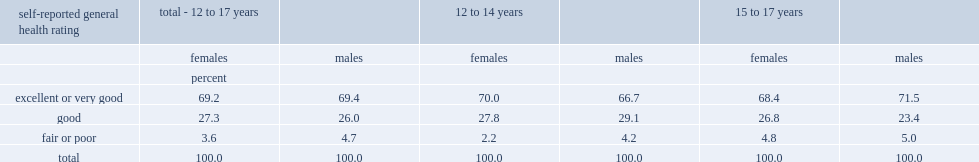What is the percentage of girls aged 12 to 17 rated their general health as "very good" or "excellent"? to 17. 69.2. What is the percentage of boys aged 12 to 17 rated their general health as "very good" or "excellent"? to 17. 69.4. Which age group were less likely to give ratings at the negative end of spectrum? 12 to 14. What is the percentage of girls aged 15 to 17 were rating "fair" and "poor"? 4.8. What is the percentage of girls aged 12 to 14 were rating "fair" and "poor"? 2.2. Which gender aged 12 to 14 were less likely to have rated their health as "poor" or "fair". Females. Which age group of boys were more likely to rate their general health as "very good" or "excellent"? Older boys. What is the percentage of older boys rated their general health as "very good" or "excellent"? 71.5. What is the percentage of younger boys rated their general health as "very good" or "excellent"? 66.7. 